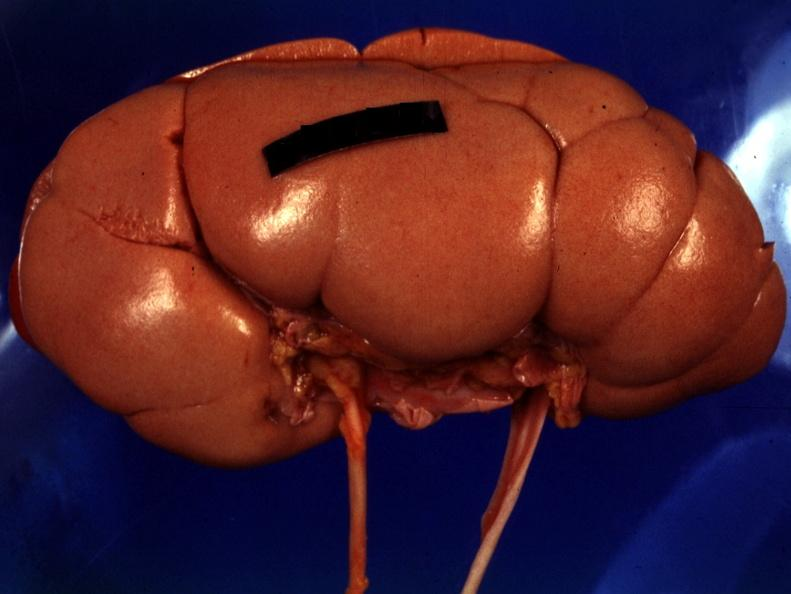s kidney present?
Answer the question using a single word or phrase. Yes 